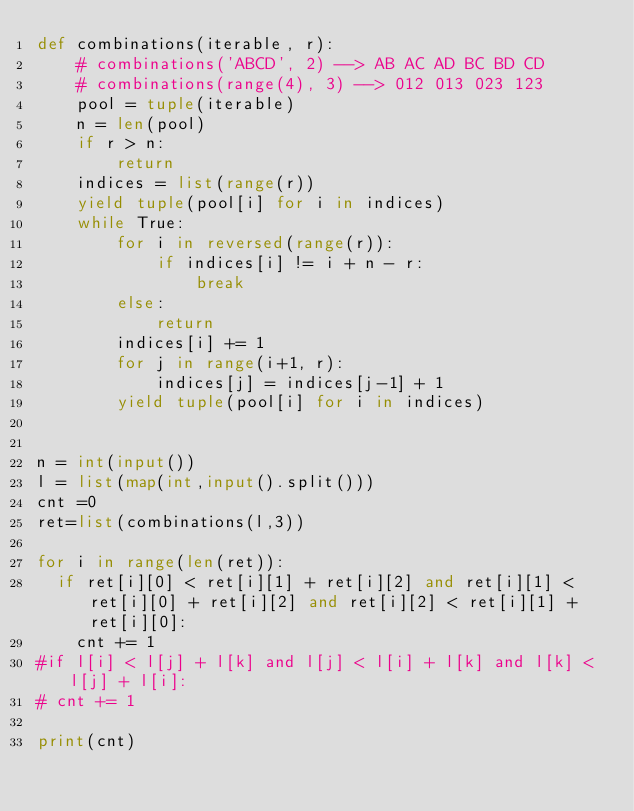<code> <loc_0><loc_0><loc_500><loc_500><_Python_>def combinations(iterable, r):
    # combinations('ABCD', 2) --> AB AC AD BC BD CD
    # combinations(range(4), 3) --> 012 013 023 123
    pool = tuple(iterable)
    n = len(pool)
    if r > n:
        return
    indices = list(range(r))
    yield tuple(pool[i] for i in indices)
    while True:
        for i in reversed(range(r)):
            if indices[i] != i + n - r:
                break
        else:
            return
        indices[i] += 1
        for j in range(i+1, r):
            indices[j] = indices[j-1] + 1
        yield tuple(pool[i] for i in indices)


n = int(input())
l = list(map(int,input().split()))
cnt =0
ret=list(combinations(l,3))

for i in range(len(ret)):
  if ret[i][0] < ret[i][1] + ret[i][2] and ret[i][1] < ret[i][0] + ret[i][2] and ret[i][2] < ret[i][1] + ret[i][0]:
    cnt += 1
#if l[i] < l[j] + l[k] and l[j] < l[i] + l[k] and l[k] < l[j] + l[i]:
#	cnt += 1

print(cnt)</code> 